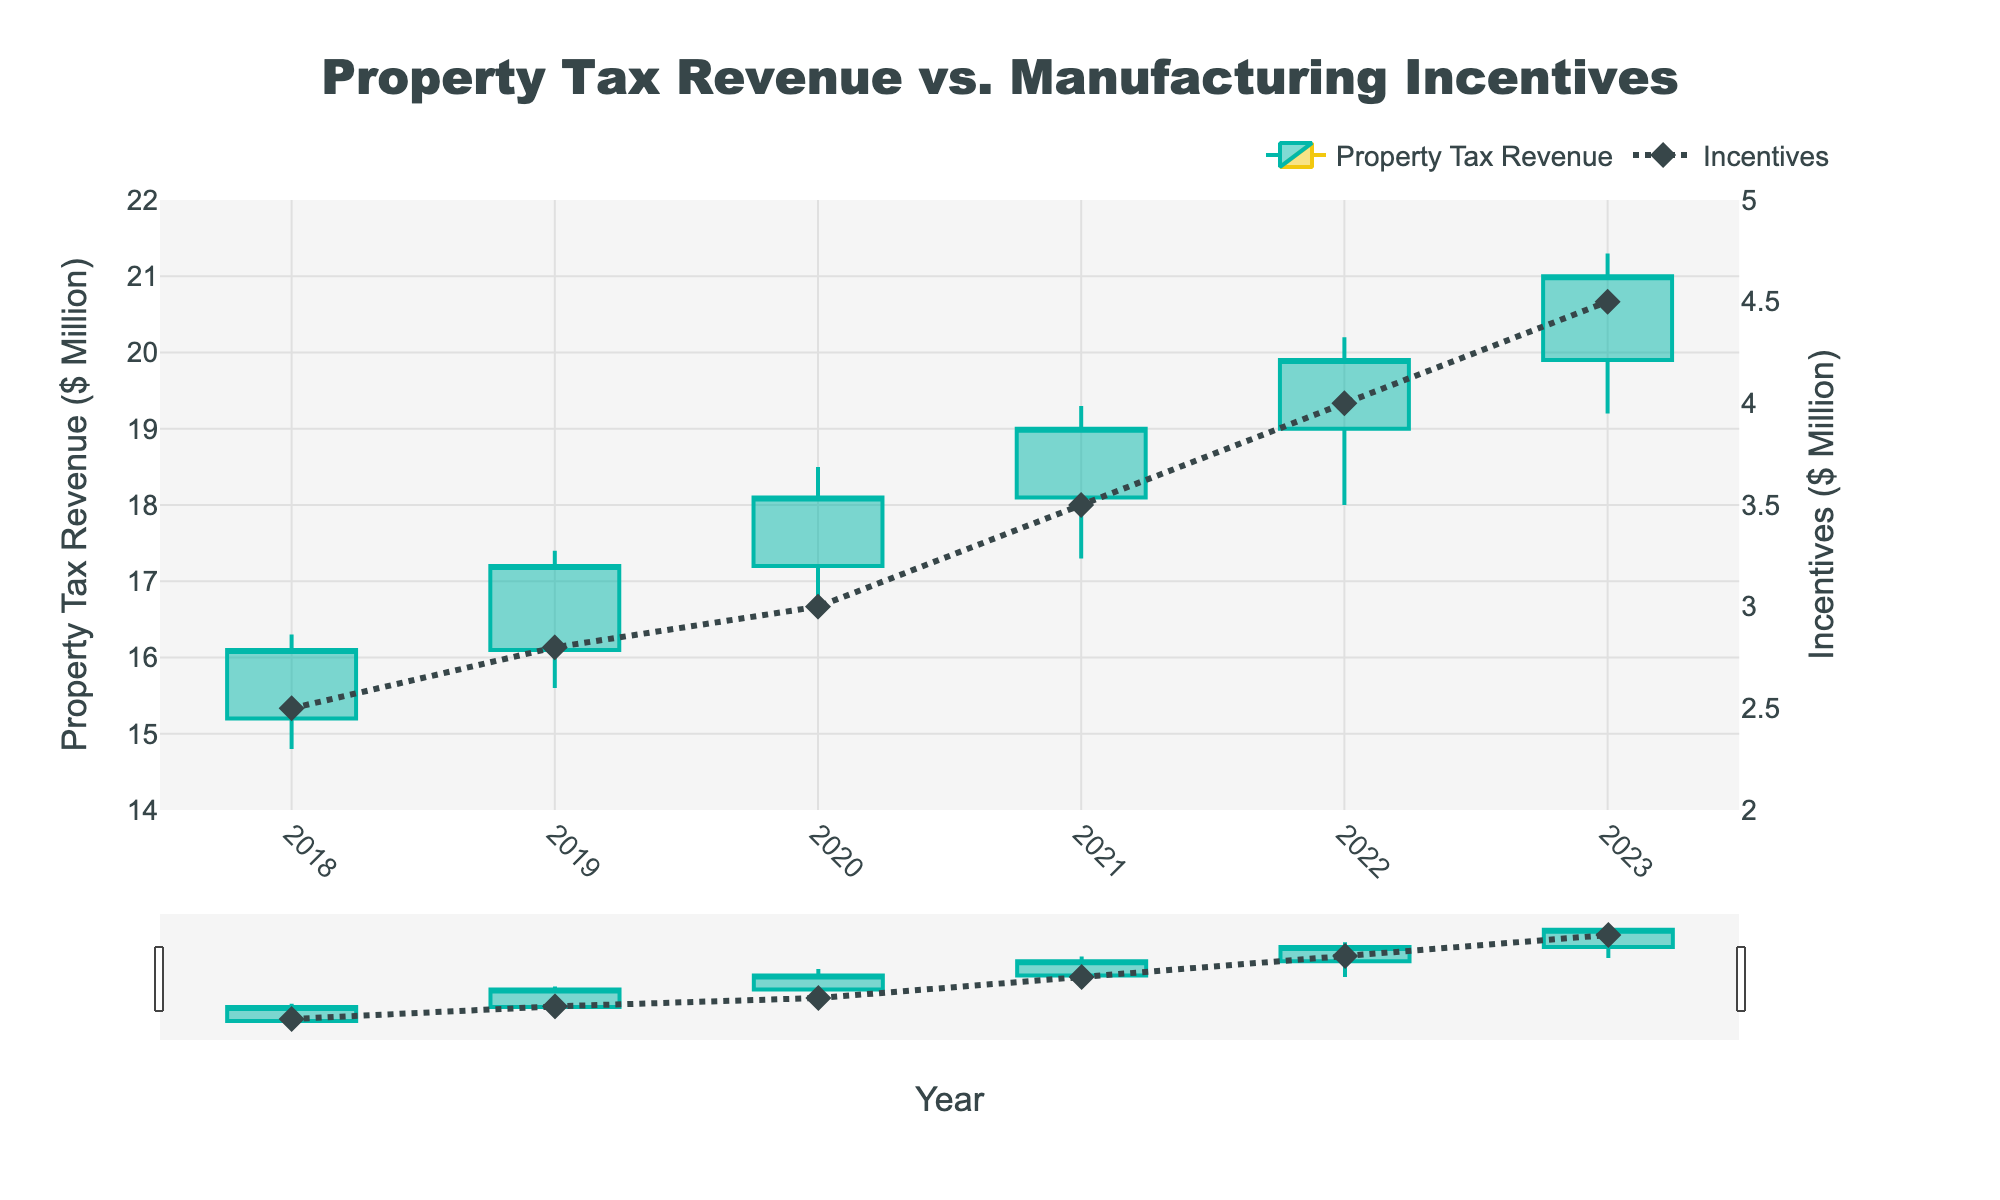What is the title of the figure? The title of the figure is displayed at the top and reads "Property Tax Revenue vs. Manufacturing Incentives".
Answer: Property Tax Revenue vs. Manufacturing Incentives How many years are covered in the plot? The x-axis shows years from 2018 to 2023, which implies the plot covers a period of 6 years.
Answer: 6 What was the property tax revenue at the end of 2021? According to the plot, the closing value of the property tax revenue for 2021 was 19.0 million dollars.
Answer: 19.0 million dollars How has the city's expenditure on incentives changed from 2020 to 2023? The value of incentives was 3.0 million dollars in 2020 and increased to 4.5 million dollars in 2023. The difference is 4.5 - 3.0 = 1.5 million dollars.
Answer: Increased by 1.5 million dollars Which year had the highest value for property tax revenue? The highest value (marked as the 'High' value in the candlestick plot) can be seen in 2023, where the property tax revenue reached 21.3 million dollars.
Answer: 2023 Compare the opening tax revenue of 2019 with the closing tax revenue of 2018. Which is higher? In 2019, the opening tax revenue was 16.1 million dollars, whereas the closing tax revenue for 2018 was 16.1 million dollars. Both values are the same.
Answer: Same What is the overall trend in property tax revenue from 2018 to 2023? The overall trend is visualized by the candlestick plot, showing generally increasing values from 2018 (open: 15.2, close: 16.1) to 2023 (open: 19.9, close: 21.0). This indicates an overall upward trend in property tax revenue.
Answer: Upward trend By how much did the property tax revenue increase from the opening of 2018 to the close of 2023? The property tax revenue opened at 15.2 million dollars in 2018 and closed at 21.0 million dollars in 2023. The increase is 21.0 - 15.2 = 5.8 million dollars.
Answer: 5.8 million dollars During which year did the city provide the highest incentives for manufacturing businesses? The secondary y-axis shows the incentives, where the highest value reached 4.5 million dollars in 2023.
Answer: 2023 